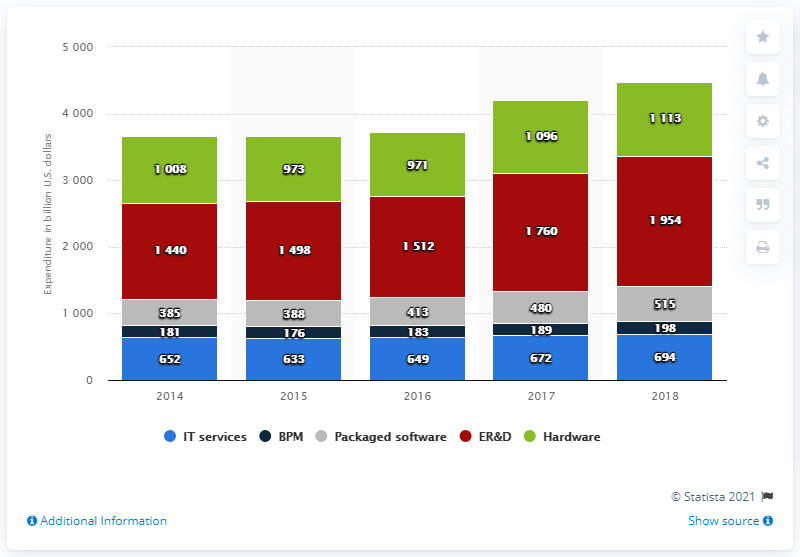Mention a couple of crucial points in this snapshot. In 2018, the global amount spent on business process management was 198.... In 2018, the market size of IT services was approximately 694... In 2014, the total market size of information technology was approximately 3666. 